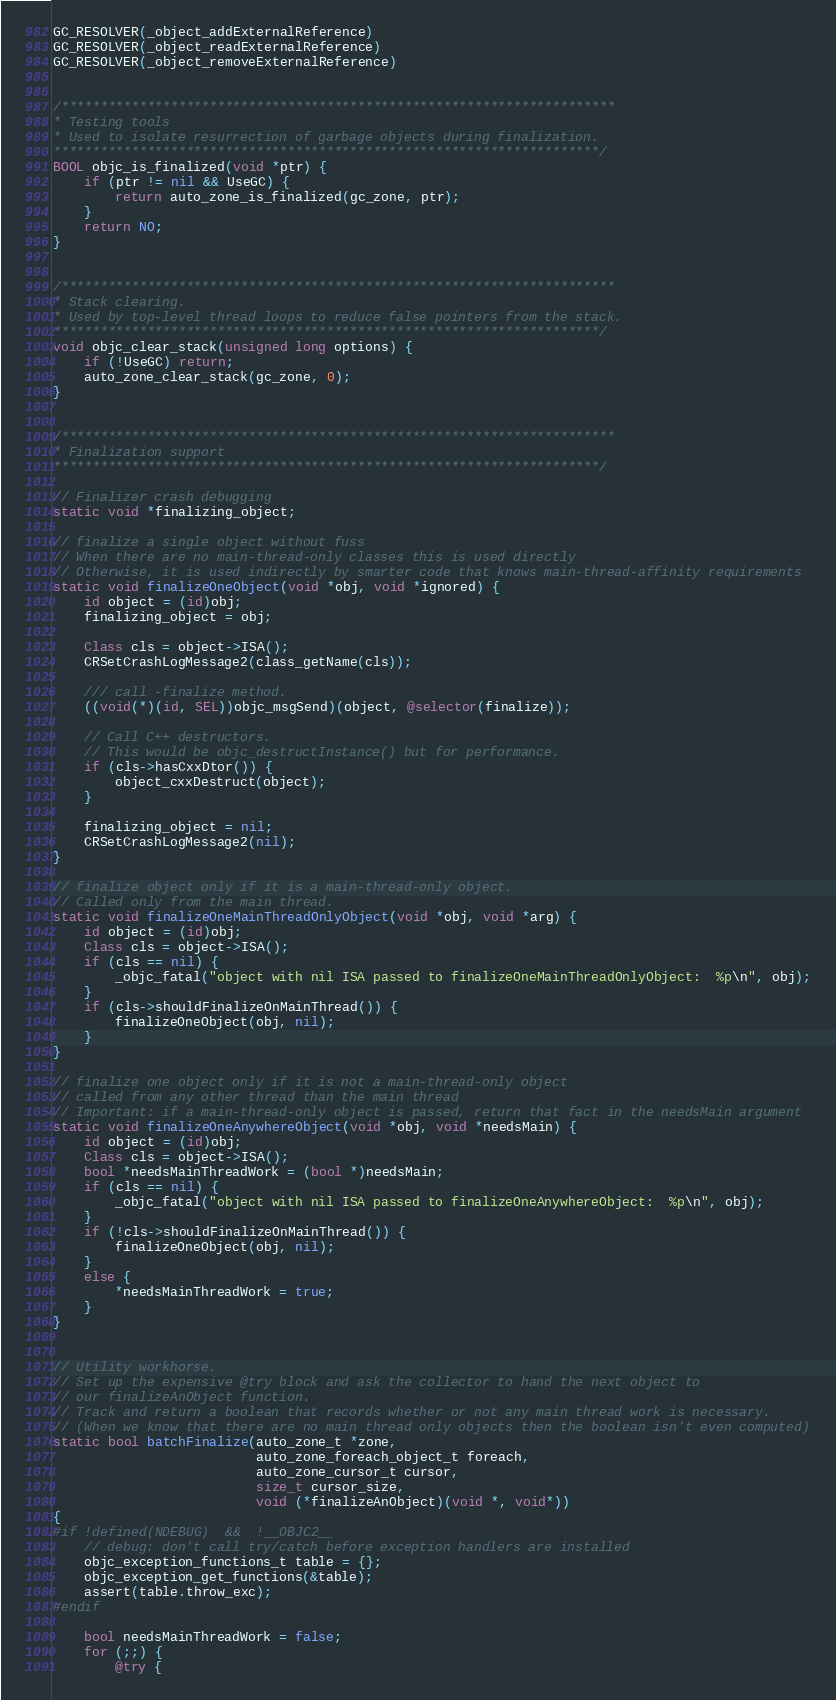<code> <loc_0><loc_0><loc_500><loc_500><_ObjectiveC_>GC_RESOLVER(_object_addExternalReference)
GC_RESOLVER(_object_readExternalReference)
GC_RESOLVER(_object_removeExternalReference)


/***********************************************************************
* Testing tools
* Used to isolate resurrection of garbage objects during finalization.
**********************************************************************/
BOOL objc_is_finalized(void *ptr) {
    if (ptr != nil && UseGC) {
        return auto_zone_is_finalized(gc_zone, ptr);
    }
    return NO;
}


/***********************************************************************
* Stack clearing.
* Used by top-level thread loops to reduce false pointers from the stack.
**********************************************************************/
void objc_clear_stack(unsigned long options) {
    if (!UseGC) return;
    auto_zone_clear_stack(gc_zone, 0);
}


/***********************************************************************
* Finalization support
**********************************************************************/

// Finalizer crash debugging
static void *finalizing_object;

// finalize a single object without fuss
// When there are no main-thread-only classes this is used directly
// Otherwise, it is used indirectly by smarter code that knows main-thread-affinity requirements
static void finalizeOneObject(void *obj, void *ignored) {
    id object = (id)obj;
    finalizing_object = obj;

    Class cls = object->ISA();
    CRSetCrashLogMessage2(class_getName(cls));

    /// call -finalize method.
    ((void(*)(id, SEL))objc_msgSend)(object, @selector(finalize));

    // Call C++ destructors. 
    // This would be objc_destructInstance() but for performance.
    if (cls->hasCxxDtor()) {
        object_cxxDestruct(object);
    }

    finalizing_object = nil;
    CRSetCrashLogMessage2(nil);
}

// finalize object only if it is a main-thread-only object.
// Called only from the main thread.
static void finalizeOneMainThreadOnlyObject(void *obj, void *arg) {
    id object = (id)obj;
    Class cls = object->ISA();
    if (cls == nil) {
        _objc_fatal("object with nil ISA passed to finalizeOneMainThreadOnlyObject:  %p\n", obj);
    }
    if (cls->shouldFinalizeOnMainThread()) {
        finalizeOneObject(obj, nil);
    }
}

// finalize one object only if it is not a main-thread-only object
// called from any other thread than the main thread
// Important: if a main-thread-only object is passed, return that fact in the needsMain argument
static void finalizeOneAnywhereObject(void *obj, void *needsMain) {
    id object = (id)obj;
    Class cls = object->ISA();
    bool *needsMainThreadWork = (bool *)needsMain;
    if (cls == nil) {
        _objc_fatal("object with nil ISA passed to finalizeOneAnywhereObject:  %p\n", obj);
    }
    if (!cls->shouldFinalizeOnMainThread()) {
        finalizeOneObject(obj, nil);
    }
    else {
        *needsMainThreadWork = true;
    }
}


// Utility workhorse.
// Set up the expensive @try block and ask the collector to hand the next object to
// our finalizeAnObject function.
// Track and return a boolean that records whether or not any main thread work is necessary.
// (When we know that there are no main thread only objects then the boolean isn't even computed)
static bool batchFinalize(auto_zone_t *zone,
                          auto_zone_foreach_object_t foreach,
                          auto_zone_cursor_t cursor, 
                          size_t cursor_size,
                          void (*finalizeAnObject)(void *, void*))
{
#if !defined(NDEBUG)  &&  !__OBJC2__
    // debug: don't call try/catch before exception handlers are installed
    objc_exception_functions_t table = {};
    objc_exception_get_functions(&table);
    assert(table.throw_exc);
#endif

    bool needsMainThreadWork = false;
    for (;;) {
        @try {</code> 